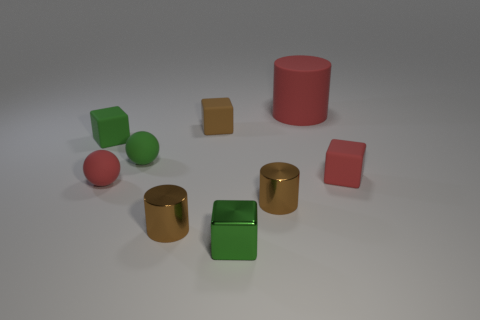Subtract all spheres. How many objects are left? 7 Add 7 small spheres. How many small spheres are left? 9 Add 5 tiny green balls. How many tiny green balls exist? 6 Subtract 1 red cubes. How many objects are left? 8 Subtract all small blocks. Subtract all tiny rubber balls. How many objects are left? 3 